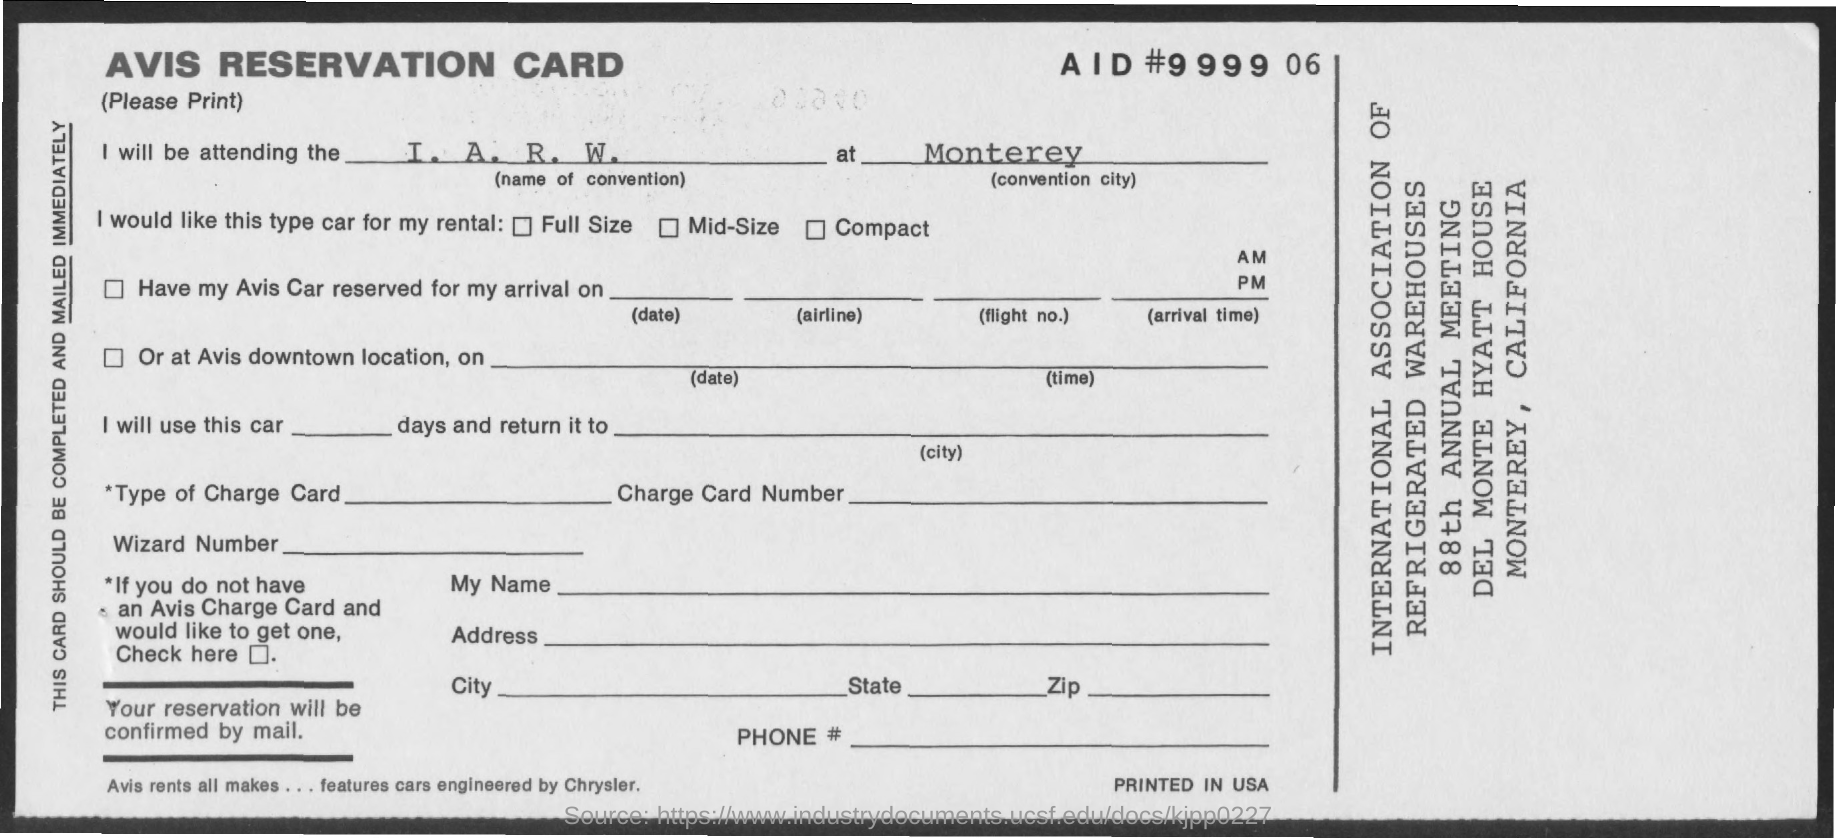What is the name of the convention mentioned ?
Your response must be concise. I. A. R. W. What is the convention city mentioned ?
Ensure brevity in your answer.  Monterey. What is the name of the card ?
Your answer should be very brief. AVIS reservation card. 